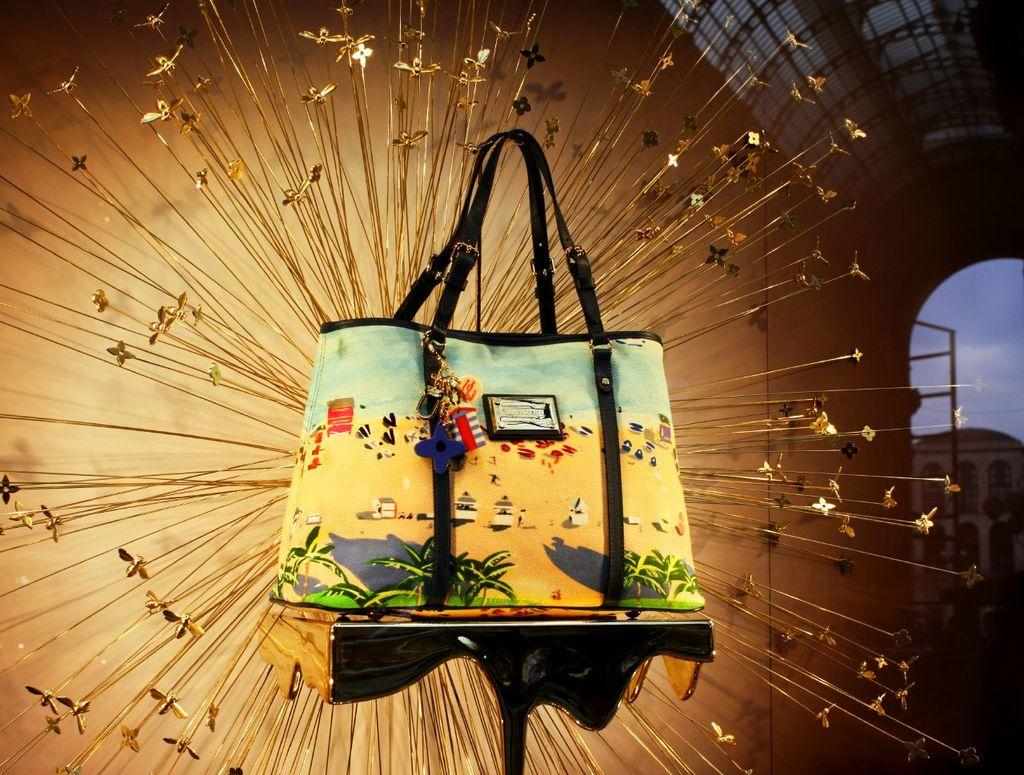What is placed on the table in the image? There is a bag on a table. What can be seen behind the table in the image? There is a decor behind the table. What hobbies are the hands engaged in within the image? There are no hands visible in the image, so it is not possible to determine any hobbies they might be engaged in. 